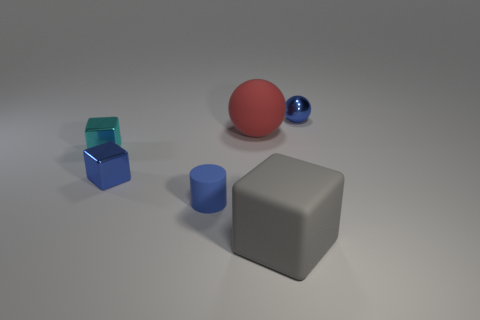What is the thing that is both right of the large ball and in front of the small blue shiny sphere made of?
Your response must be concise. Rubber. What is the color of the sphere that is the same size as the cyan thing?
Keep it short and to the point. Blue. Are the tiny blue ball and the cube right of the cylinder made of the same material?
Offer a terse response. No. What number of other objects are the same size as the gray rubber cube?
Provide a succinct answer. 1. Are there any big gray blocks that are in front of the blue thing behind the blue shiny object that is to the left of the blue metal sphere?
Your answer should be very brief. Yes. The blue cylinder has what size?
Your answer should be compact. Small. How big is the metallic thing that is right of the large block?
Keep it short and to the point. Small. There is a ball that is on the left side of the blue shiny ball; does it have the same size as the big gray rubber cube?
Your answer should be very brief. Yes. Is there anything else that has the same color as the matte cylinder?
Your response must be concise. Yes. There is a small blue rubber thing; what shape is it?
Provide a succinct answer. Cylinder. 